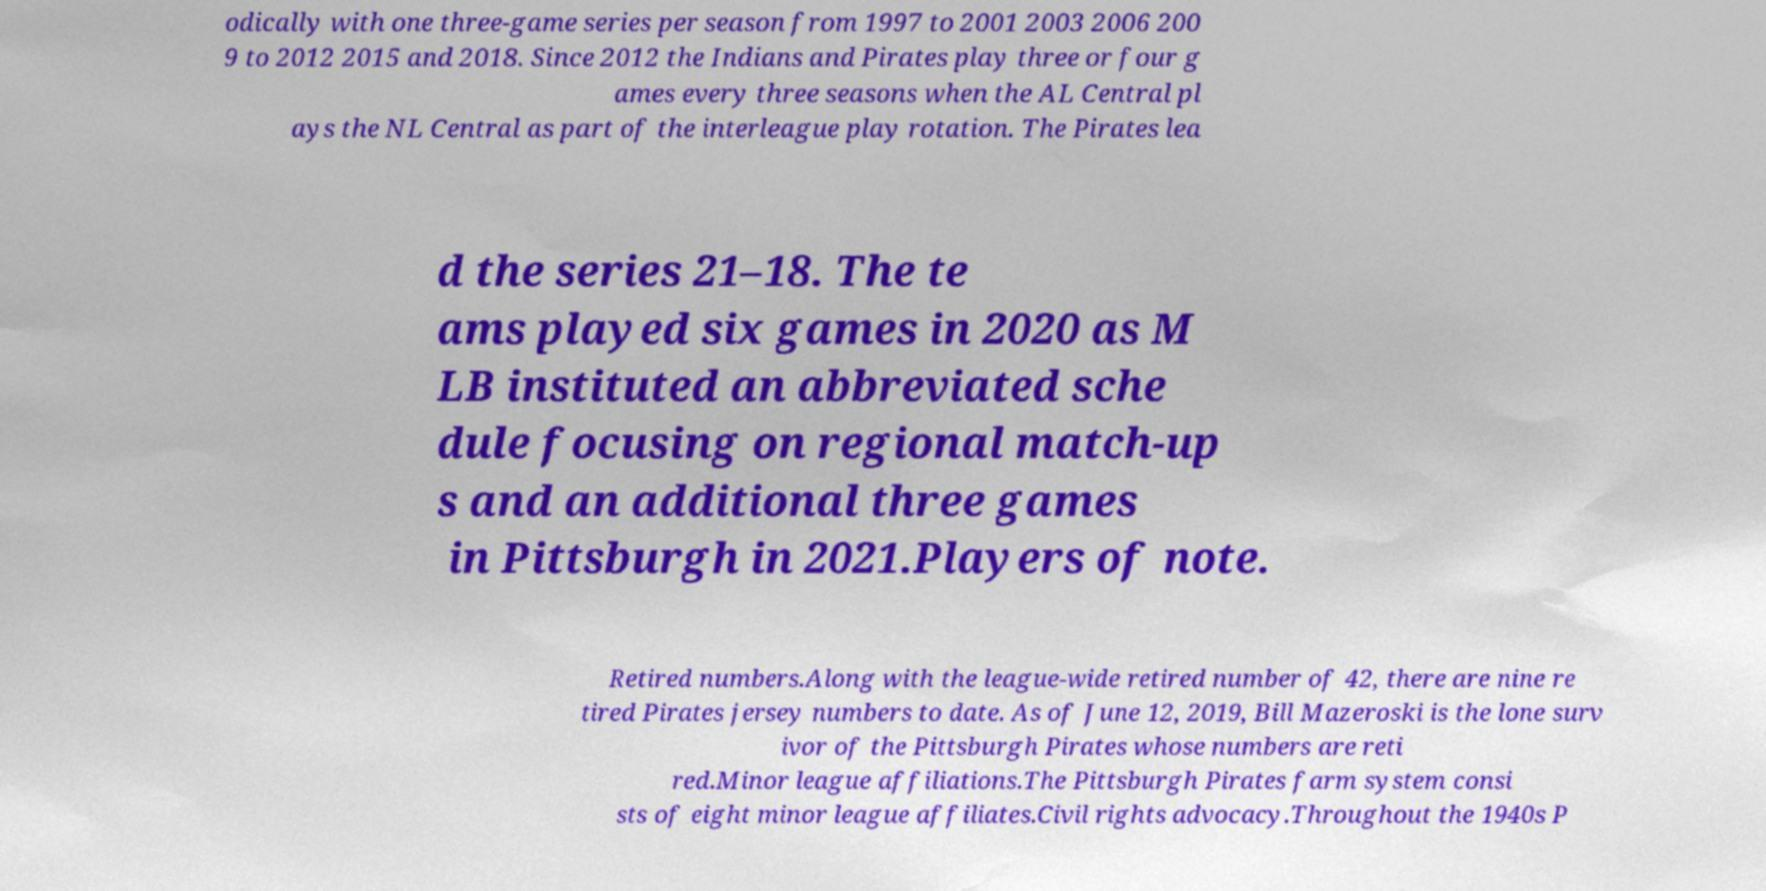Please identify and transcribe the text found in this image. odically with one three-game series per season from 1997 to 2001 2003 2006 200 9 to 2012 2015 and 2018. Since 2012 the Indians and Pirates play three or four g ames every three seasons when the AL Central pl ays the NL Central as part of the interleague play rotation. The Pirates lea d the series 21–18. The te ams played six games in 2020 as M LB instituted an abbreviated sche dule focusing on regional match-up s and an additional three games in Pittsburgh in 2021.Players of note. Retired numbers.Along with the league-wide retired number of 42, there are nine re tired Pirates jersey numbers to date. As of June 12, 2019, Bill Mazeroski is the lone surv ivor of the Pittsburgh Pirates whose numbers are reti red.Minor league affiliations.The Pittsburgh Pirates farm system consi sts of eight minor league affiliates.Civil rights advocacy.Throughout the 1940s P 